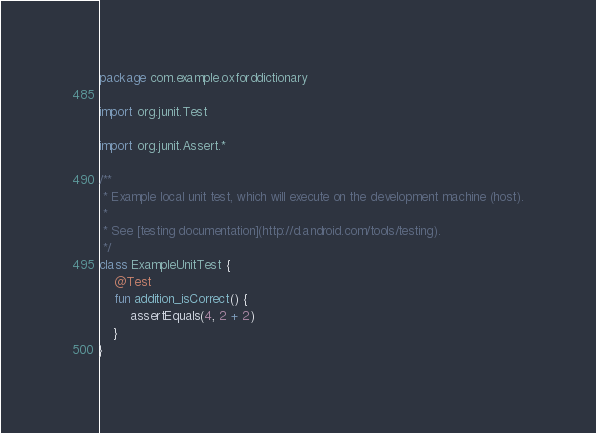Convert code to text. <code><loc_0><loc_0><loc_500><loc_500><_Kotlin_>package com.example.oxforddictionary

import org.junit.Test

import org.junit.Assert.*

/**
 * Example local unit test, which will execute on the development machine (host).
 *
 * See [testing documentation](http://d.android.com/tools/testing).
 */
class ExampleUnitTest {
    @Test
    fun addition_isCorrect() {
        assertEquals(4, 2 + 2)
    }
}</code> 